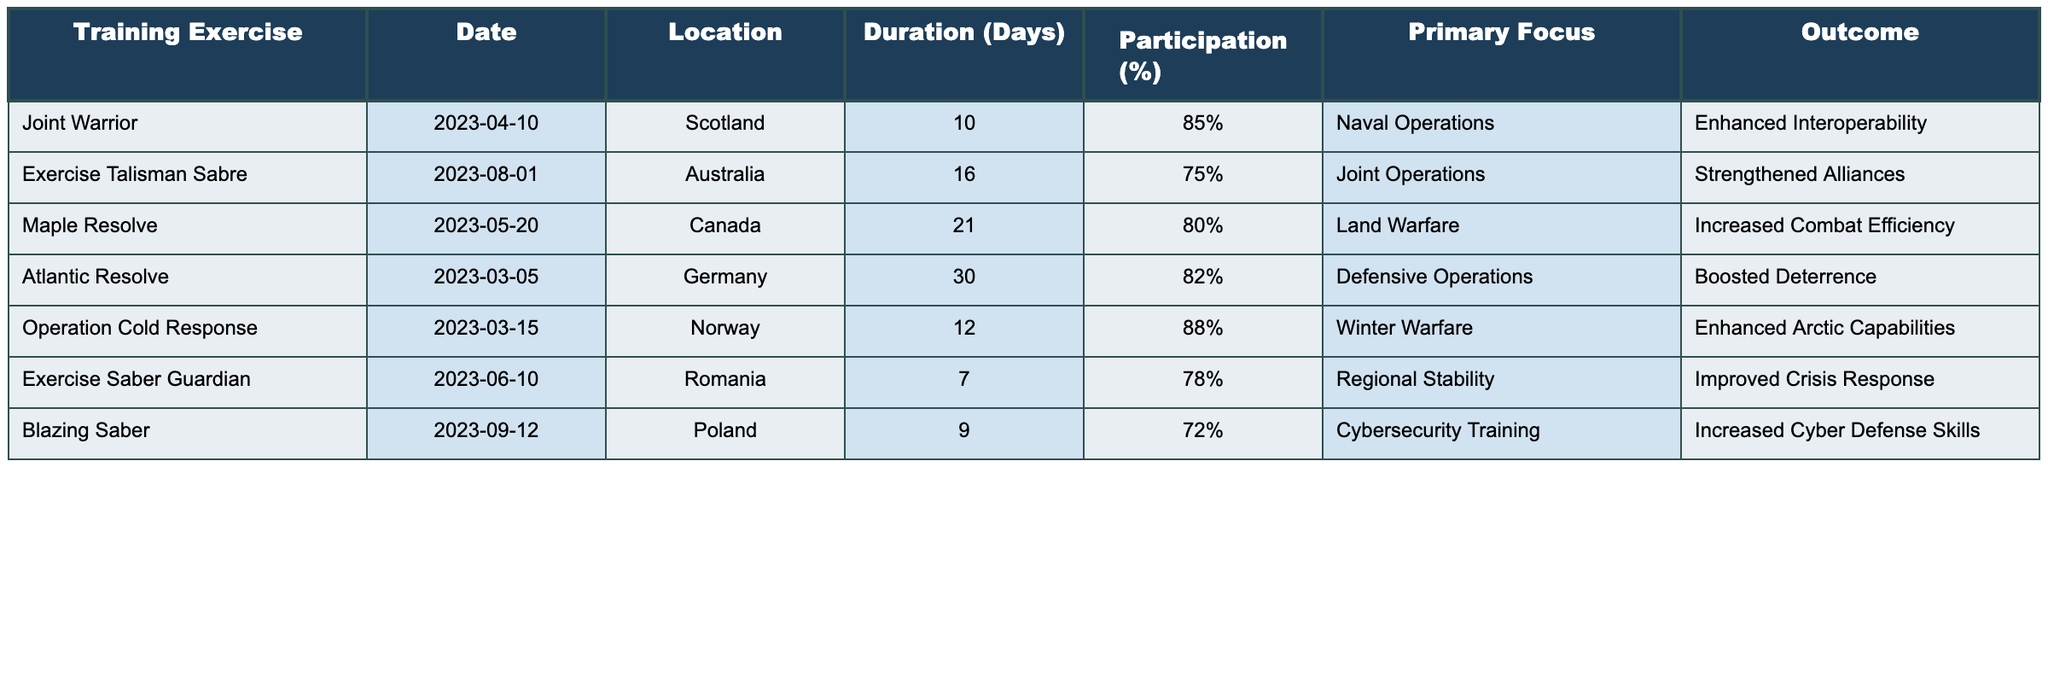What is the participation percentage for Operation Cold Response? Referring to the table, the row for "Operation Cold Response" shows that the participation percentage is **88%**.
Answer: 88% Which training exercise had the longest duration? By examining the "Duration (Days)" column, "Atlantic Resolve" has the longest duration of **30 days** compared to other exercises.
Answer: 30 days How many exercises focused on Land Warfare? The table lists "Maple Resolve" as the only exercise focusing on "Land Warfare," indicating that there is **1 exercise** in this category.
Answer: 1 What was the outcome of the Exercise Talisman Sabre? The "Outcome" column for "Exercise Talisman Sabre" states that the outcome was **Strengthened Alliances**.
Answer: Strengthened Alliances What is the average participation percentage across all exercises? Adding all participation percentages: 85 + 75 + 80 + 82 + 88 + 78 + 72 = 540. There are 7 exercises, so the average is 540/7 = **77.14%**.
Answer: 77.14% Which training exercises took place in the summer months (June to August)? Checking the "Date" column, "Exercise Saber Guardian" (June) and "Exercise Talisman Sabre" (August) occurred during summer months, totaling **2 exercises**.
Answer: 2 exercises Did any training exercise have more than 80% participation? Looking at the "Participation (%)" column, both "Operation Cold Response" (88%) and "Joint Warrior" (85%) had more than 80% participation, making it **True**.
Answer: True Which primary focus had the lowest participation percentage? Comparing the "Participation (%)" column, "Blazing Saber" with a participation of **72%** has the lowest participation among those listed.
Answer: 72% What is the combined duration of the exercises held in Canada and Norway? The durations for "Maple Resolve" (21 days) and "Operation Cold Response" (12 days) sum to 21 + 12 = **33 days** combined.
Answer: 33 days Which exercise had the primary focus on Cybersecurity Training? The "Primary Focus" column indicates that **Blazing Saber** had a focus on Cybersecurity Training.
Answer: Blazing Saber 